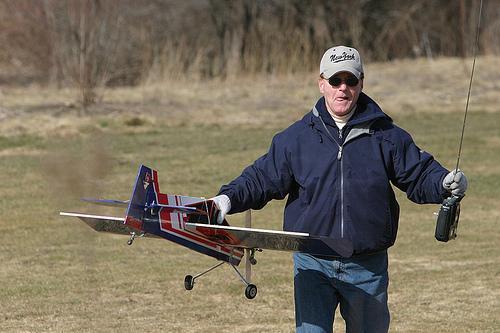How many people are in the picture?
Give a very brief answer. 1. 